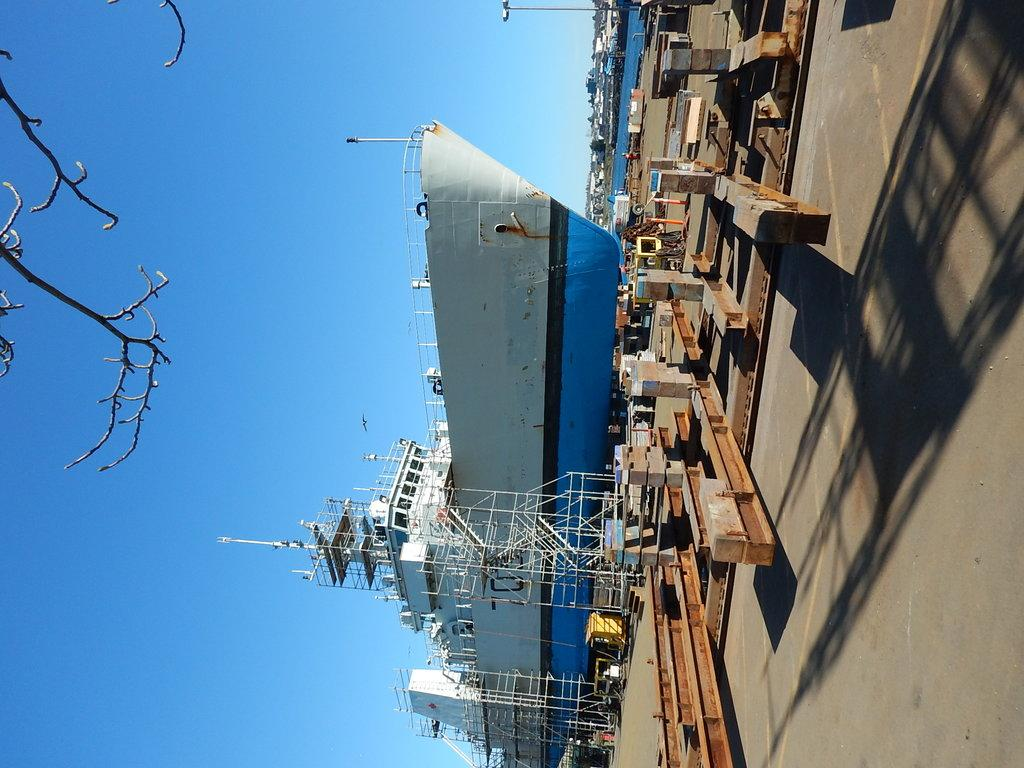What is the main subject of the image? The main subject of the image is a boat. Where is the boat located? The boat is in the sea. How is the image presented? The image is inverted. What else can be seen in the image besides the boat? There is a road with metal frames and the sky is visible in the image. What type of skin condition can be seen on the boat in the image? There is no skin condition present on the boat in the image, as boats do not have skin. 